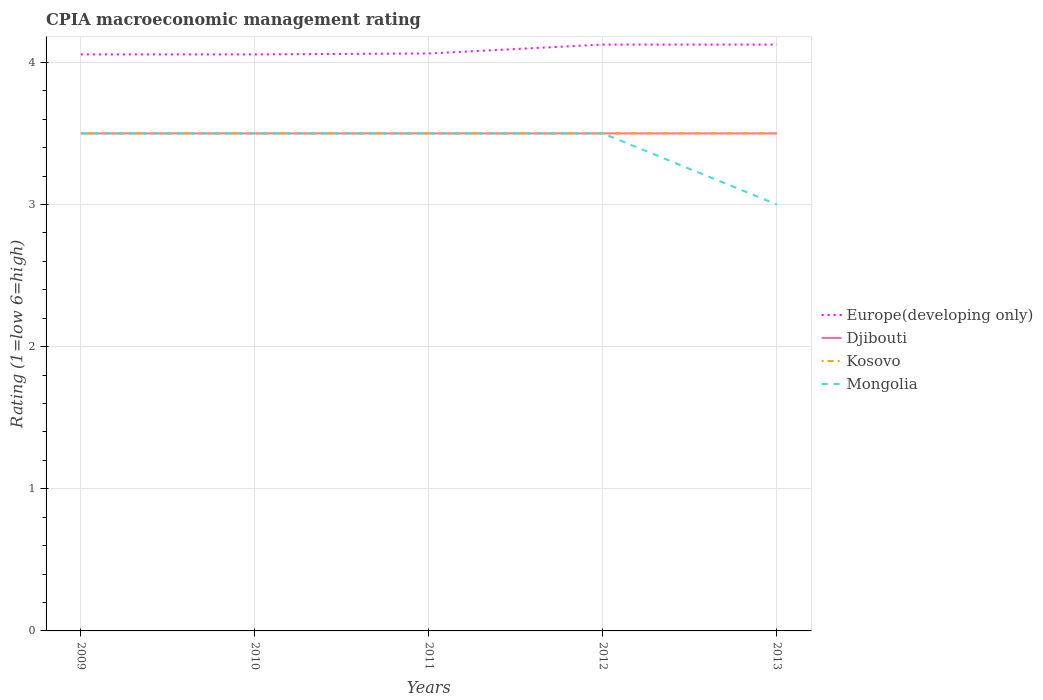Does the line corresponding to Kosovo intersect with the line corresponding to Europe(developing only)?
Provide a short and direct response. No. What is the total CPIA rating in Mongolia in the graph?
Keep it short and to the point. 0. Is the CPIA rating in Europe(developing only) strictly greater than the CPIA rating in Kosovo over the years?
Keep it short and to the point. No. How many lines are there?
Give a very brief answer. 4. How many years are there in the graph?
Offer a terse response. 5. What is the difference between two consecutive major ticks on the Y-axis?
Ensure brevity in your answer.  1. Does the graph contain any zero values?
Your response must be concise. No. What is the title of the graph?
Your response must be concise. CPIA macroeconomic management rating. What is the label or title of the Y-axis?
Provide a short and direct response. Rating (1=low 6=high). What is the Rating (1=low 6=high) of Europe(developing only) in 2009?
Offer a very short reply. 4.06. What is the Rating (1=low 6=high) in Djibouti in 2009?
Your answer should be compact. 3.5. What is the Rating (1=low 6=high) in Kosovo in 2009?
Give a very brief answer. 3.5. What is the Rating (1=low 6=high) of Mongolia in 2009?
Offer a very short reply. 3.5. What is the Rating (1=low 6=high) in Europe(developing only) in 2010?
Make the answer very short. 4.06. What is the Rating (1=low 6=high) of Kosovo in 2010?
Keep it short and to the point. 3.5. What is the Rating (1=low 6=high) of Europe(developing only) in 2011?
Give a very brief answer. 4.06. What is the Rating (1=low 6=high) in Kosovo in 2011?
Your response must be concise. 3.5. What is the Rating (1=low 6=high) in Mongolia in 2011?
Your answer should be very brief. 3.5. What is the Rating (1=low 6=high) in Europe(developing only) in 2012?
Your response must be concise. 4.12. What is the Rating (1=low 6=high) of Kosovo in 2012?
Ensure brevity in your answer.  3.5. What is the Rating (1=low 6=high) in Mongolia in 2012?
Your answer should be compact. 3.5. What is the Rating (1=low 6=high) of Europe(developing only) in 2013?
Keep it short and to the point. 4.12. Across all years, what is the maximum Rating (1=low 6=high) in Europe(developing only)?
Your answer should be very brief. 4.12. Across all years, what is the maximum Rating (1=low 6=high) in Kosovo?
Offer a terse response. 3.5. Across all years, what is the minimum Rating (1=low 6=high) of Europe(developing only)?
Your answer should be compact. 4.06. What is the total Rating (1=low 6=high) of Europe(developing only) in the graph?
Provide a succinct answer. 20.42. What is the total Rating (1=low 6=high) of Kosovo in the graph?
Give a very brief answer. 17.5. What is the total Rating (1=low 6=high) of Mongolia in the graph?
Offer a very short reply. 17. What is the difference between the Rating (1=low 6=high) in Europe(developing only) in 2009 and that in 2010?
Your answer should be very brief. 0. What is the difference between the Rating (1=low 6=high) in Djibouti in 2009 and that in 2010?
Your answer should be very brief. 0. What is the difference between the Rating (1=low 6=high) of Kosovo in 2009 and that in 2010?
Make the answer very short. 0. What is the difference between the Rating (1=low 6=high) in Mongolia in 2009 and that in 2010?
Offer a terse response. 0. What is the difference between the Rating (1=low 6=high) in Europe(developing only) in 2009 and that in 2011?
Your answer should be very brief. -0.01. What is the difference between the Rating (1=low 6=high) in Djibouti in 2009 and that in 2011?
Make the answer very short. 0. What is the difference between the Rating (1=low 6=high) in Kosovo in 2009 and that in 2011?
Your answer should be very brief. 0. What is the difference between the Rating (1=low 6=high) of Europe(developing only) in 2009 and that in 2012?
Make the answer very short. -0.07. What is the difference between the Rating (1=low 6=high) in Djibouti in 2009 and that in 2012?
Provide a short and direct response. 0. What is the difference between the Rating (1=low 6=high) of Mongolia in 2009 and that in 2012?
Provide a succinct answer. 0. What is the difference between the Rating (1=low 6=high) of Europe(developing only) in 2009 and that in 2013?
Keep it short and to the point. -0.07. What is the difference between the Rating (1=low 6=high) in Djibouti in 2009 and that in 2013?
Offer a very short reply. 0. What is the difference between the Rating (1=low 6=high) in Europe(developing only) in 2010 and that in 2011?
Your response must be concise. -0.01. What is the difference between the Rating (1=low 6=high) in Djibouti in 2010 and that in 2011?
Offer a very short reply. 0. What is the difference between the Rating (1=low 6=high) in Kosovo in 2010 and that in 2011?
Provide a succinct answer. 0. What is the difference between the Rating (1=low 6=high) in Mongolia in 2010 and that in 2011?
Offer a terse response. 0. What is the difference between the Rating (1=low 6=high) of Europe(developing only) in 2010 and that in 2012?
Keep it short and to the point. -0.07. What is the difference between the Rating (1=low 6=high) of Djibouti in 2010 and that in 2012?
Your answer should be very brief. 0. What is the difference between the Rating (1=low 6=high) in Kosovo in 2010 and that in 2012?
Give a very brief answer. 0. What is the difference between the Rating (1=low 6=high) in Europe(developing only) in 2010 and that in 2013?
Offer a very short reply. -0.07. What is the difference between the Rating (1=low 6=high) of Djibouti in 2010 and that in 2013?
Your answer should be very brief. 0. What is the difference between the Rating (1=low 6=high) of Europe(developing only) in 2011 and that in 2012?
Your answer should be compact. -0.06. What is the difference between the Rating (1=low 6=high) of Kosovo in 2011 and that in 2012?
Your response must be concise. 0. What is the difference between the Rating (1=low 6=high) in Mongolia in 2011 and that in 2012?
Your answer should be very brief. 0. What is the difference between the Rating (1=low 6=high) of Europe(developing only) in 2011 and that in 2013?
Give a very brief answer. -0.06. What is the difference between the Rating (1=low 6=high) in Djibouti in 2011 and that in 2013?
Provide a succinct answer. 0. What is the difference between the Rating (1=low 6=high) of Kosovo in 2011 and that in 2013?
Provide a short and direct response. 0. What is the difference between the Rating (1=low 6=high) of Djibouti in 2012 and that in 2013?
Offer a very short reply. 0. What is the difference between the Rating (1=low 6=high) of Europe(developing only) in 2009 and the Rating (1=low 6=high) of Djibouti in 2010?
Offer a terse response. 0.56. What is the difference between the Rating (1=low 6=high) of Europe(developing only) in 2009 and the Rating (1=low 6=high) of Kosovo in 2010?
Provide a succinct answer. 0.56. What is the difference between the Rating (1=low 6=high) of Europe(developing only) in 2009 and the Rating (1=low 6=high) of Mongolia in 2010?
Ensure brevity in your answer.  0.56. What is the difference between the Rating (1=low 6=high) in Djibouti in 2009 and the Rating (1=low 6=high) in Kosovo in 2010?
Your response must be concise. 0. What is the difference between the Rating (1=low 6=high) of Djibouti in 2009 and the Rating (1=low 6=high) of Mongolia in 2010?
Ensure brevity in your answer.  0. What is the difference between the Rating (1=low 6=high) of Europe(developing only) in 2009 and the Rating (1=low 6=high) of Djibouti in 2011?
Your response must be concise. 0.56. What is the difference between the Rating (1=low 6=high) in Europe(developing only) in 2009 and the Rating (1=low 6=high) in Kosovo in 2011?
Provide a short and direct response. 0.56. What is the difference between the Rating (1=low 6=high) of Europe(developing only) in 2009 and the Rating (1=low 6=high) of Mongolia in 2011?
Make the answer very short. 0.56. What is the difference between the Rating (1=low 6=high) of Europe(developing only) in 2009 and the Rating (1=low 6=high) of Djibouti in 2012?
Offer a terse response. 0.56. What is the difference between the Rating (1=low 6=high) in Europe(developing only) in 2009 and the Rating (1=low 6=high) in Kosovo in 2012?
Give a very brief answer. 0.56. What is the difference between the Rating (1=low 6=high) of Europe(developing only) in 2009 and the Rating (1=low 6=high) of Mongolia in 2012?
Keep it short and to the point. 0.56. What is the difference between the Rating (1=low 6=high) of Djibouti in 2009 and the Rating (1=low 6=high) of Mongolia in 2012?
Ensure brevity in your answer.  0. What is the difference between the Rating (1=low 6=high) of Kosovo in 2009 and the Rating (1=low 6=high) of Mongolia in 2012?
Provide a succinct answer. 0. What is the difference between the Rating (1=low 6=high) in Europe(developing only) in 2009 and the Rating (1=low 6=high) in Djibouti in 2013?
Your answer should be compact. 0.56. What is the difference between the Rating (1=low 6=high) in Europe(developing only) in 2009 and the Rating (1=low 6=high) in Kosovo in 2013?
Give a very brief answer. 0.56. What is the difference between the Rating (1=low 6=high) in Europe(developing only) in 2009 and the Rating (1=low 6=high) in Mongolia in 2013?
Provide a short and direct response. 1.06. What is the difference between the Rating (1=low 6=high) in Djibouti in 2009 and the Rating (1=low 6=high) in Kosovo in 2013?
Offer a very short reply. 0. What is the difference between the Rating (1=low 6=high) in Djibouti in 2009 and the Rating (1=low 6=high) in Mongolia in 2013?
Provide a succinct answer. 0.5. What is the difference between the Rating (1=low 6=high) of Kosovo in 2009 and the Rating (1=low 6=high) of Mongolia in 2013?
Provide a short and direct response. 0.5. What is the difference between the Rating (1=low 6=high) of Europe(developing only) in 2010 and the Rating (1=low 6=high) of Djibouti in 2011?
Keep it short and to the point. 0.56. What is the difference between the Rating (1=low 6=high) in Europe(developing only) in 2010 and the Rating (1=low 6=high) in Kosovo in 2011?
Your response must be concise. 0.56. What is the difference between the Rating (1=low 6=high) in Europe(developing only) in 2010 and the Rating (1=low 6=high) in Mongolia in 2011?
Provide a short and direct response. 0.56. What is the difference between the Rating (1=low 6=high) of Kosovo in 2010 and the Rating (1=low 6=high) of Mongolia in 2011?
Your answer should be compact. 0. What is the difference between the Rating (1=low 6=high) of Europe(developing only) in 2010 and the Rating (1=low 6=high) of Djibouti in 2012?
Offer a very short reply. 0.56. What is the difference between the Rating (1=low 6=high) of Europe(developing only) in 2010 and the Rating (1=low 6=high) of Kosovo in 2012?
Make the answer very short. 0.56. What is the difference between the Rating (1=low 6=high) of Europe(developing only) in 2010 and the Rating (1=low 6=high) of Mongolia in 2012?
Provide a short and direct response. 0.56. What is the difference between the Rating (1=low 6=high) of Djibouti in 2010 and the Rating (1=low 6=high) of Mongolia in 2012?
Make the answer very short. 0. What is the difference between the Rating (1=low 6=high) of Europe(developing only) in 2010 and the Rating (1=low 6=high) of Djibouti in 2013?
Ensure brevity in your answer.  0.56. What is the difference between the Rating (1=low 6=high) of Europe(developing only) in 2010 and the Rating (1=low 6=high) of Kosovo in 2013?
Your answer should be very brief. 0.56. What is the difference between the Rating (1=low 6=high) of Europe(developing only) in 2010 and the Rating (1=low 6=high) of Mongolia in 2013?
Give a very brief answer. 1.06. What is the difference between the Rating (1=low 6=high) in Djibouti in 2010 and the Rating (1=low 6=high) in Kosovo in 2013?
Provide a succinct answer. 0. What is the difference between the Rating (1=low 6=high) of Djibouti in 2010 and the Rating (1=low 6=high) of Mongolia in 2013?
Provide a succinct answer. 0.5. What is the difference between the Rating (1=low 6=high) in Europe(developing only) in 2011 and the Rating (1=low 6=high) in Djibouti in 2012?
Keep it short and to the point. 0.56. What is the difference between the Rating (1=low 6=high) in Europe(developing only) in 2011 and the Rating (1=low 6=high) in Kosovo in 2012?
Provide a short and direct response. 0.56. What is the difference between the Rating (1=low 6=high) of Europe(developing only) in 2011 and the Rating (1=low 6=high) of Mongolia in 2012?
Ensure brevity in your answer.  0.56. What is the difference between the Rating (1=low 6=high) of Djibouti in 2011 and the Rating (1=low 6=high) of Kosovo in 2012?
Ensure brevity in your answer.  0. What is the difference between the Rating (1=low 6=high) of Djibouti in 2011 and the Rating (1=low 6=high) of Mongolia in 2012?
Your response must be concise. 0. What is the difference between the Rating (1=low 6=high) of Kosovo in 2011 and the Rating (1=low 6=high) of Mongolia in 2012?
Your answer should be very brief. 0. What is the difference between the Rating (1=low 6=high) of Europe(developing only) in 2011 and the Rating (1=low 6=high) of Djibouti in 2013?
Offer a very short reply. 0.56. What is the difference between the Rating (1=low 6=high) in Europe(developing only) in 2011 and the Rating (1=low 6=high) in Kosovo in 2013?
Provide a succinct answer. 0.56. What is the difference between the Rating (1=low 6=high) in Djibouti in 2011 and the Rating (1=low 6=high) in Kosovo in 2013?
Make the answer very short. 0. What is the difference between the Rating (1=low 6=high) in Djibouti in 2011 and the Rating (1=low 6=high) in Mongolia in 2013?
Offer a very short reply. 0.5. What is the difference between the Rating (1=low 6=high) of Kosovo in 2011 and the Rating (1=low 6=high) of Mongolia in 2013?
Provide a short and direct response. 0.5. What is the difference between the Rating (1=low 6=high) in Europe(developing only) in 2012 and the Rating (1=low 6=high) in Djibouti in 2013?
Your response must be concise. 0.62. What is the difference between the Rating (1=low 6=high) in Djibouti in 2012 and the Rating (1=low 6=high) in Mongolia in 2013?
Your answer should be compact. 0.5. What is the average Rating (1=low 6=high) of Europe(developing only) per year?
Offer a very short reply. 4.08. What is the average Rating (1=low 6=high) in Kosovo per year?
Ensure brevity in your answer.  3.5. What is the average Rating (1=low 6=high) in Mongolia per year?
Ensure brevity in your answer.  3.4. In the year 2009, what is the difference between the Rating (1=low 6=high) of Europe(developing only) and Rating (1=low 6=high) of Djibouti?
Make the answer very short. 0.56. In the year 2009, what is the difference between the Rating (1=low 6=high) in Europe(developing only) and Rating (1=low 6=high) in Kosovo?
Give a very brief answer. 0.56. In the year 2009, what is the difference between the Rating (1=low 6=high) in Europe(developing only) and Rating (1=low 6=high) in Mongolia?
Your answer should be very brief. 0.56. In the year 2010, what is the difference between the Rating (1=low 6=high) in Europe(developing only) and Rating (1=low 6=high) in Djibouti?
Make the answer very short. 0.56. In the year 2010, what is the difference between the Rating (1=low 6=high) of Europe(developing only) and Rating (1=low 6=high) of Kosovo?
Give a very brief answer. 0.56. In the year 2010, what is the difference between the Rating (1=low 6=high) in Europe(developing only) and Rating (1=low 6=high) in Mongolia?
Provide a succinct answer. 0.56. In the year 2010, what is the difference between the Rating (1=low 6=high) of Kosovo and Rating (1=low 6=high) of Mongolia?
Your answer should be compact. 0. In the year 2011, what is the difference between the Rating (1=low 6=high) in Europe(developing only) and Rating (1=low 6=high) in Djibouti?
Your answer should be compact. 0.56. In the year 2011, what is the difference between the Rating (1=low 6=high) in Europe(developing only) and Rating (1=low 6=high) in Kosovo?
Your response must be concise. 0.56. In the year 2011, what is the difference between the Rating (1=low 6=high) in Europe(developing only) and Rating (1=low 6=high) in Mongolia?
Provide a succinct answer. 0.56. In the year 2011, what is the difference between the Rating (1=low 6=high) of Djibouti and Rating (1=low 6=high) of Kosovo?
Your answer should be compact. 0. In the year 2011, what is the difference between the Rating (1=low 6=high) in Djibouti and Rating (1=low 6=high) in Mongolia?
Offer a very short reply. 0. In the year 2012, what is the difference between the Rating (1=low 6=high) of Europe(developing only) and Rating (1=low 6=high) of Kosovo?
Your answer should be very brief. 0.62. In the year 2012, what is the difference between the Rating (1=low 6=high) in Djibouti and Rating (1=low 6=high) in Mongolia?
Give a very brief answer. 0. In the year 2013, what is the difference between the Rating (1=low 6=high) of Europe(developing only) and Rating (1=low 6=high) of Kosovo?
Your answer should be compact. 0.62. In the year 2013, what is the difference between the Rating (1=low 6=high) of Europe(developing only) and Rating (1=low 6=high) of Mongolia?
Ensure brevity in your answer.  1.12. In the year 2013, what is the difference between the Rating (1=low 6=high) in Djibouti and Rating (1=low 6=high) in Mongolia?
Your response must be concise. 0.5. In the year 2013, what is the difference between the Rating (1=low 6=high) in Kosovo and Rating (1=low 6=high) in Mongolia?
Your response must be concise. 0.5. What is the ratio of the Rating (1=low 6=high) in Mongolia in 2009 to that in 2010?
Your answer should be compact. 1. What is the ratio of the Rating (1=low 6=high) of Europe(developing only) in 2009 to that in 2011?
Your response must be concise. 1. What is the ratio of the Rating (1=low 6=high) of Djibouti in 2009 to that in 2011?
Provide a succinct answer. 1. What is the ratio of the Rating (1=low 6=high) in Europe(developing only) in 2009 to that in 2012?
Your response must be concise. 0.98. What is the ratio of the Rating (1=low 6=high) in Djibouti in 2009 to that in 2012?
Keep it short and to the point. 1. What is the ratio of the Rating (1=low 6=high) in Europe(developing only) in 2009 to that in 2013?
Offer a terse response. 0.98. What is the ratio of the Rating (1=low 6=high) of Europe(developing only) in 2010 to that in 2011?
Make the answer very short. 1. What is the ratio of the Rating (1=low 6=high) in Europe(developing only) in 2010 to that in 2012?
Your answer should be very brief. 0.98. What is the ratio of the Rating (1=low 6=high) in Kosovo in 2010 to that in 2012?
Provide a succinct answer. 1. What is the ratio of the Rating (1=low 6=high) of Europe(developing only) in 2010 to that in 2013?
Provide a succinct answer. 0.98. What is the ratio of the Rating (1=low 6=high) of Kosovo in 2011 to that in 2012?
Offer a terse response. 1. What is the ratio of the Rating (1=low 6=high) in Mongolia in 2011 to that in 2012?
Provide a succinct answer. 1. What is the ratio of the Rating (1=low 6=high) in Europe(developing only) in 2011 to that in 2013?
Make the answer very short. 0.98. What is the ratio of the Rating (1=low 6=high) of Djibouti in 2011 to that in 2013?
Keep it short and to the point. 1. What is the ratio of the Rating (1=low 6=high) in Kosovo in 2011 to that in 2013?
Ensure brevity in your answer.  1. What is the ratio of the Rating (1=low 6=high) of Mongolia in 2011 to that in 2013?
Keep it short and to the point. 1.17. What is the difference between the highest and the second highest Rating (1=low 6=high) of Europe(developing only)?
Make the answer very short. 0. What is the difference between the highest and the second highest Rating (1=low 6=high) of Mongolia?
Your answer should be compact. 0. What is the difference between the highest and the lowest Rating (1=low 6=high) in Europe(developing only)?
Keep it short and to the point. 0.07. What is the difference between the highest and the lowest Rating (1=low 6=high) in Mongolia?
Your answer should be compact. 0.5. 